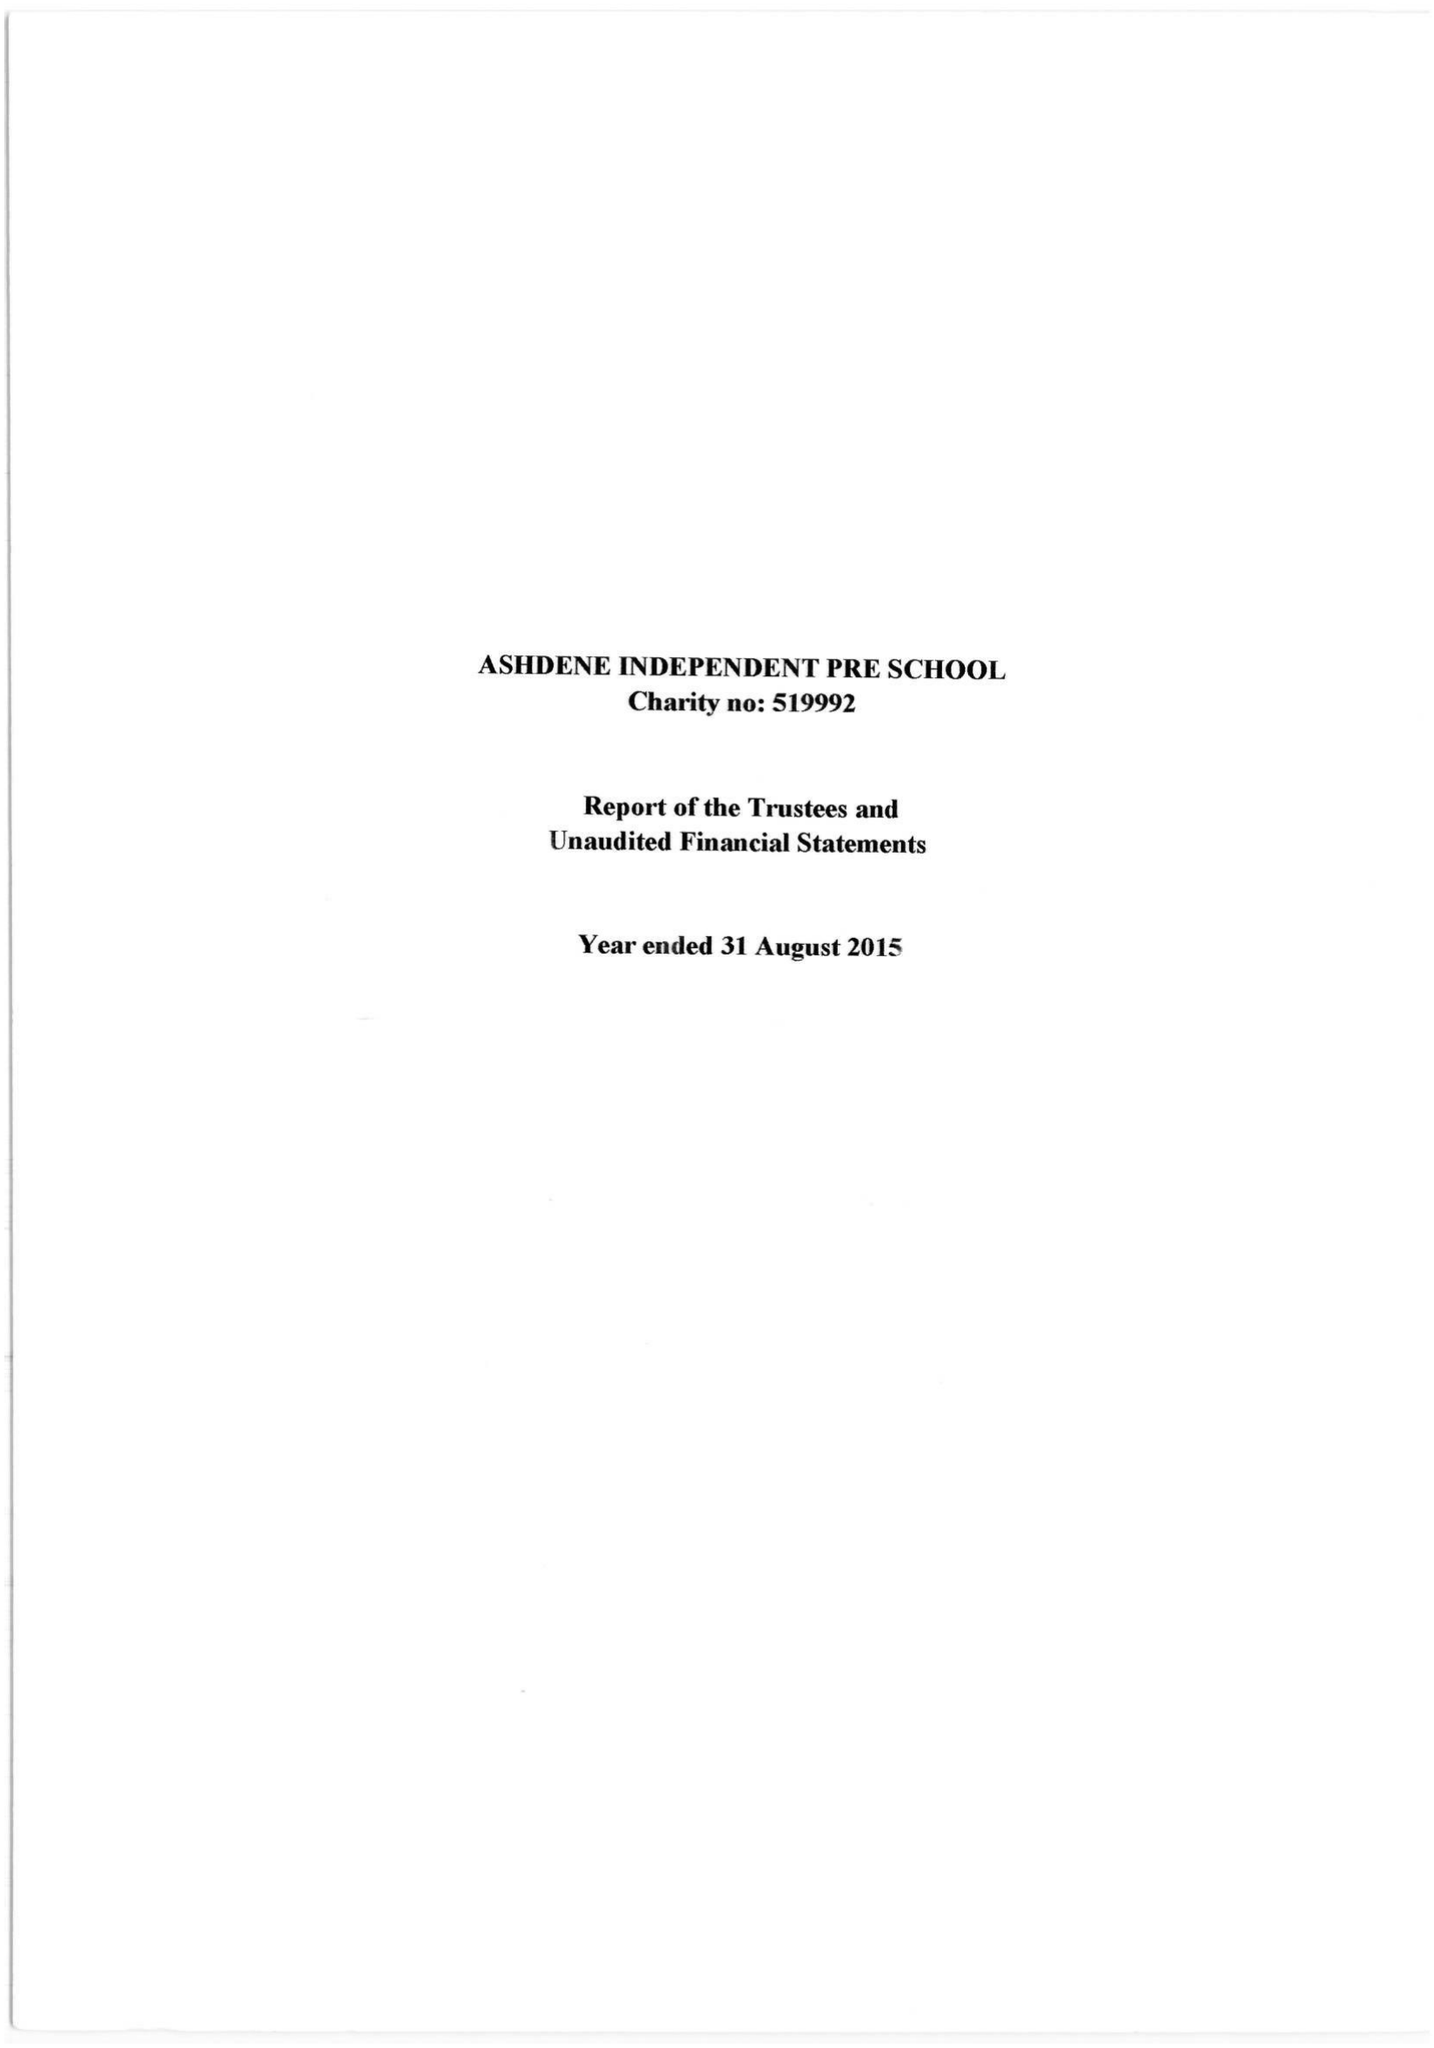What is the value for the address__street_line?
Answer the question using a single word or phrase. None 